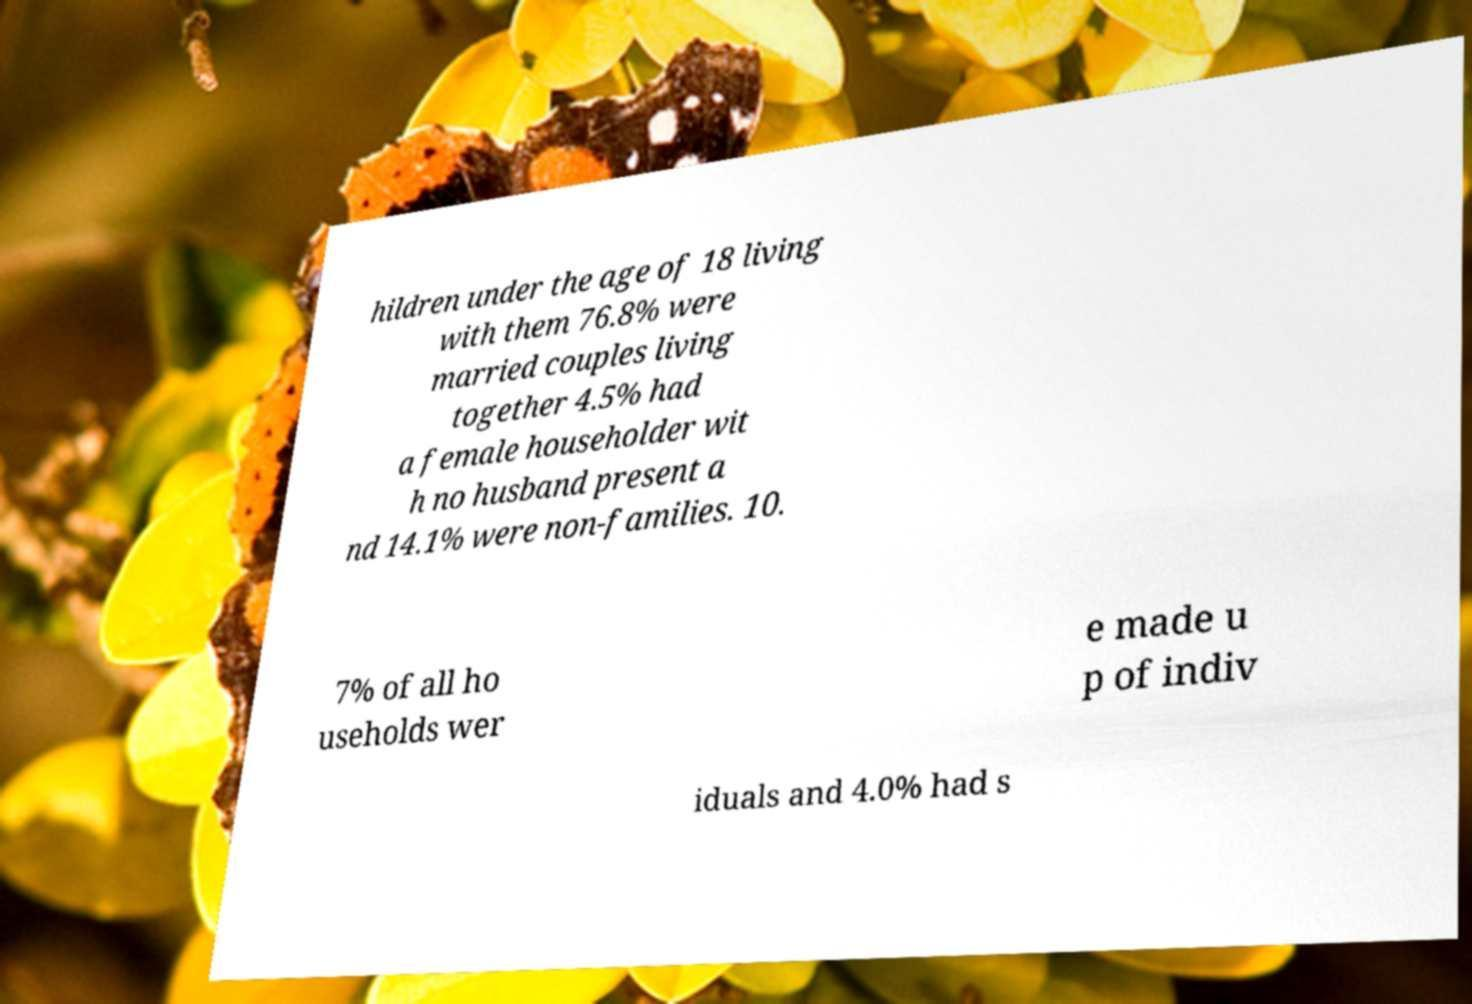Could you assist in decoding the text presented in this image and type it out clearly? hildren under the age of 18 living with them 76.8% were married couples living together 4.5% had a female householder wit h no husband present a nd 14.1% were non-families. 10. 7% of all ho useholds wer e made u p of indiv iduals and 4.0% had s 